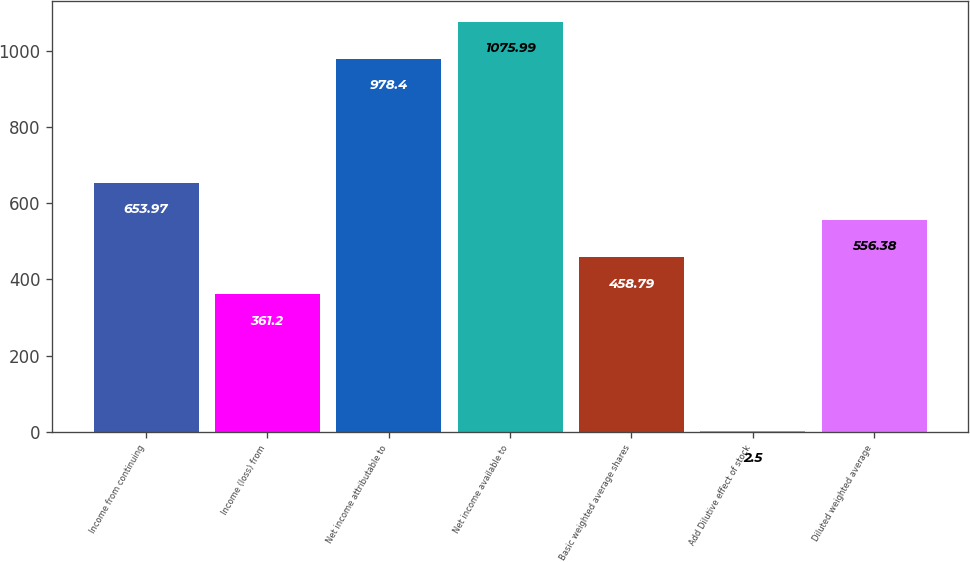Convert chart. <chart><loc_0><loc_0><loc_500><loc_500><bar_chart><fcel>Income from continuing<fcel>Income (loss) from<fcel>Net income attributable to<fcel>Net income available to<fcel>Basic weighted average shares<fcel>Add Dilutive effect of stock<fcel>Diluted weighted average<nl><fcel>653.97<fcel>361.2<fcel>978.4<fcel>1075.99<fcel>458.79<fcel>2.5<fcel>556.38<nl></chart> 